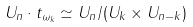<formula> <loc_0><loc_0><loc_500><loc_500>U _ { n } \cdot t _ { \omega _ { k } } \simeq U _ { n } / ( U _ { k } \times U _ { n - k } )</formula> 